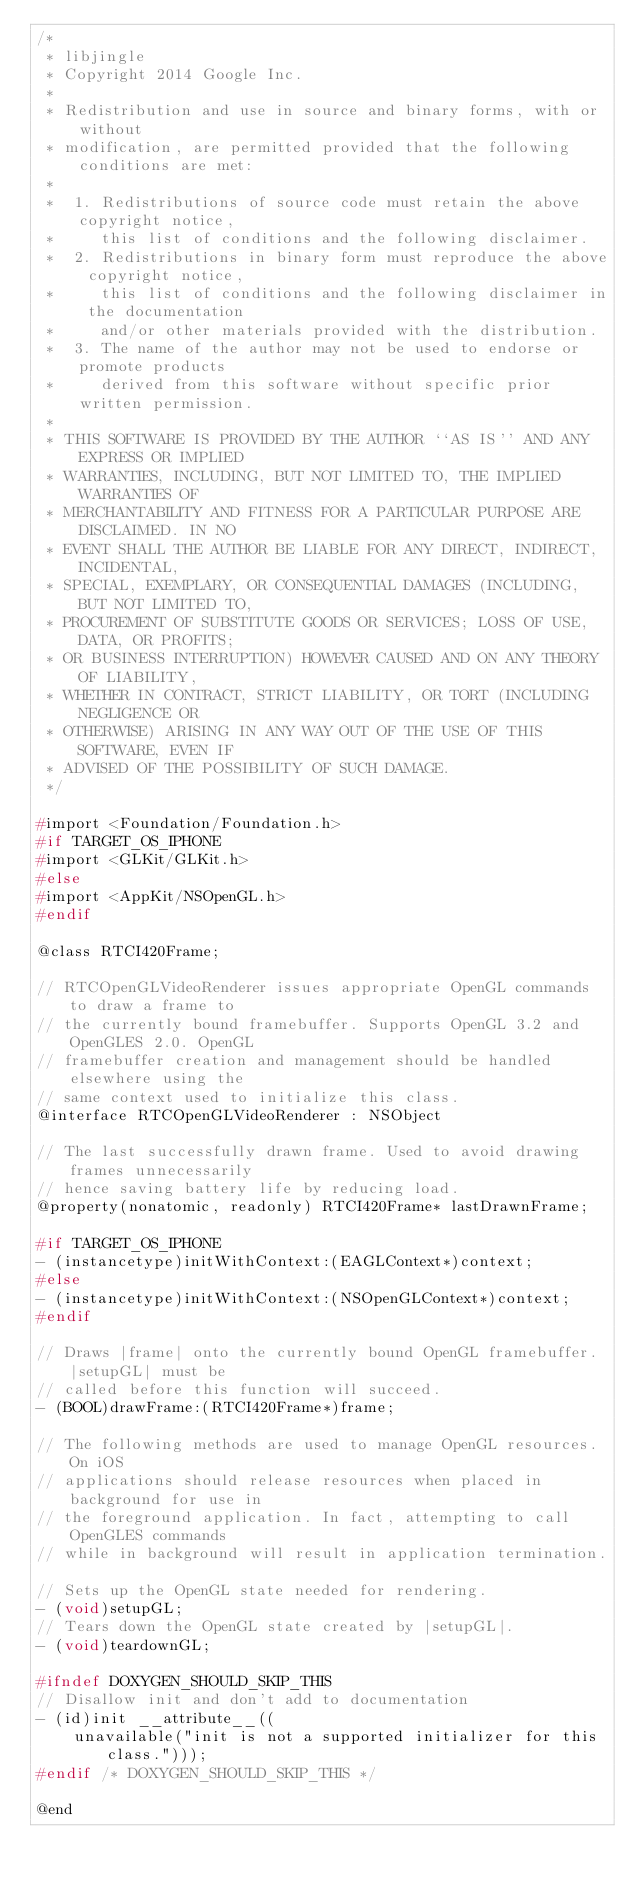<code> <loc_0><loc_0><loc_500><loc_500><_C_>/*
 * libjingle
 * Copyright 2014 Google Inc.
 *
 * Redistribution and use in source and binary forms, with or without
 * modification, are permitted provided that the following conditions are met:
 *
 *  1. Redistributions of source code must retain the above copyright notice,
 *     this list of conditions and the following disclaimer.
 *  2. Redistributions in binary form must reproduce the above copyright notice,
 *     this list of conditions and the following disclaimer in the documentation
 *     and/or other materials provided with the distribution.
 *  3. The name of the author may not be used to endorse or promote products
 *     derived from this software without specific prior written permission.
 *
 * THIS SOFTWARE IS PROVIDED BY THE AUTHOR ``AS IS'' AND ANY EXPRESS OR IMPLIED
 * WARRANTIES, INCLUDING, BUT NOT LIMITED TO, THE IMPLIED WARRANTIES OF
 * MERCHANTABILITY AND FITNESS FOR A PARTICULAR PURPOSE ARE DISCLAIMED. IN NO
 * EVENT SHALL THE AUTHOR BE LIABLE FOR ANY DIRECT, INDIRECT, INCIDENTAL,
 * SPECIAL, EXEMPLARY, OR CONSEQUENTIAL DAMAGES (INCLUDING, BUT NOT LIMITED TO,
 * PROCUREMENT OF SUBSTITUTE GOODS OR SERVICES; LOSS OF USE, DATA, OR PROFITS;
 * OR BUSINESS INTERRUPTION) HOWEVER CAUSED AND ON ANY THEORY OF LIABILITY,
 * WHETHER IN CONTRACT, STRICT LIABILITY, OR TORT (INCLUDING NEGLIGENCE OR
 * OTHERWISE) ARISING IN ANY WAY OUT OF THE USE OF THIS SOFTWARE, EVEN IF
 * ADVISED OF THE POSSIBILITY OF SUCH DAMAGE.
 */

#import <Foundation/Foundation.h>
#if TARGET_OS_IPHONE
#import <GLKit/GLKit.h>
#else
#import <AppKit/NSOpenGL.h>
#endif

@class RTCI420Frame;

// RTCOpenGLVideoRenderer issues appropriate OpenGL commands to draw a frame to
// the currently bound framebuffer. Supports OpenGL 3.2 and OpenGLES 2.0. OpenGL
// framebuffer creation and management should be handled elsewhere using the
// same context used to initialize this class.
@interface RTCOpenGLVideoRenderer : NSObject

// The last successfully drawn frame. Used to avoid drawing frames unnecessarily
// hence saving battery life by reducing load.
@property(nonatomic, readonly) RTCI420Frame* lastDrawnFrame;

#if TARGET_OS_IPHONE
- (instancetype)initWithContext:(EAGLContext*)context;
#else
- (instancetype)initWithContext:(NSOpenGLContext*)context;
#endif

// Draws |frame| onto the currently bound OpenGL framebuffer. |setupGL| must be
// called before this function will succeed.
- (BOOL)drawFrame:(RTCI420Frame*)frame;

// The following methods are used to manage OpenGL resources. On iOS
// applications should release resources when placed in background for use in
// the foreground application. In fact, attempting to call OpenGLES commands
// while in background will result in application termination.

// Sets up the OpenGL state needed for rendering.
- (void)setupGL;
// Tears down the OpenGL state created by |setupGL|.
- (void)teardownGL;

#ifndef DOXYGEN_SHOULD_SKIP_THIS
// Disallow init and don't add to documentation
- (id)init __attribute__((
    unavailable("init is not a supported initializer for this class.")));
#endif /* DOXYGEN_SHOULD_SKIP_THIS */

@end
</code> 